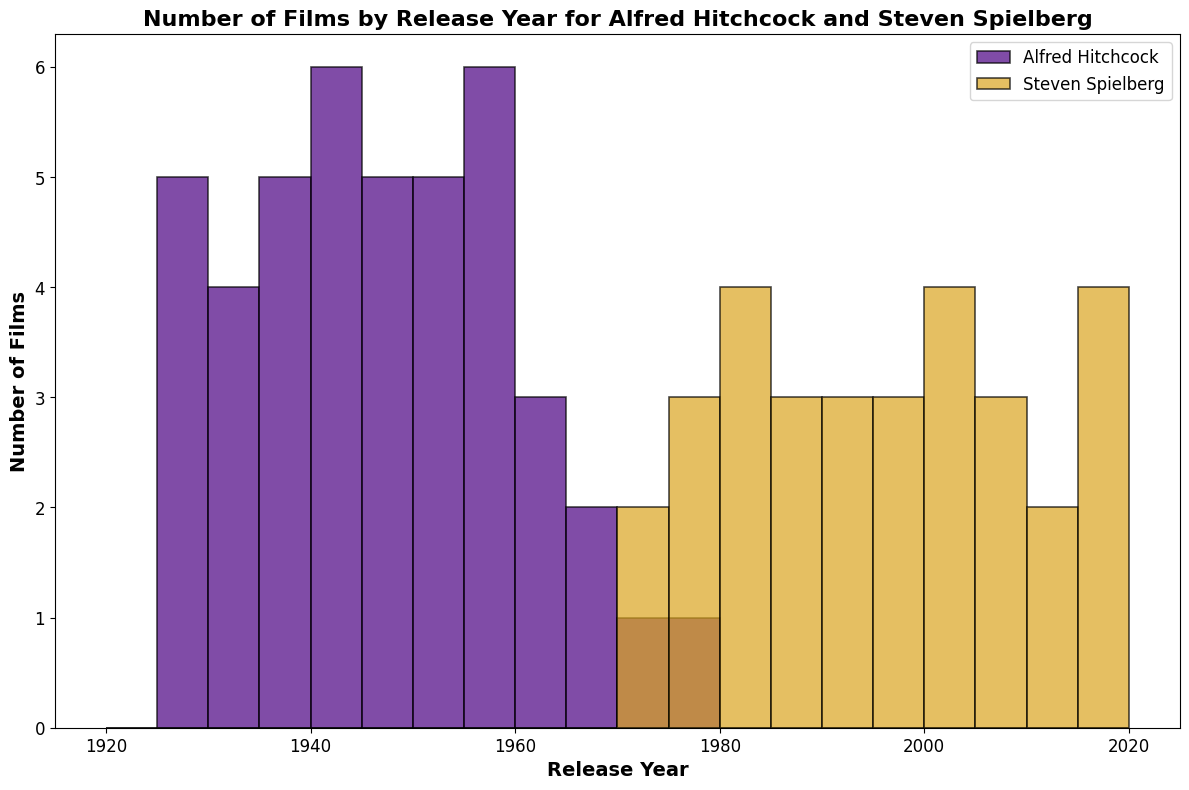Which director has more films released in the 1980s? To determine which director released more films in the 1980s, check the height of the bars corresponding to the years 1980-1989 for both directors. Spielberg has several films in this period, while Hitchcock has none. Therefore, Spielberg has more films in the 1980s.
Answer: Spielberg How many films did Alfred Hitchcock release between 1925 and 1940? Check the bars corresponding to Hitchcock's films for the years 1925 to 1940 and count the total number of films released. Adding up the values, the counts are 1 (1925), 2 (1927), 1 (1928), 1 (1929), 1 (1930), 1 (1931), 1 (1932), 1 (1934), 1 (1935), 2 (1936), 1 (1938), 1 (1939), 2 (1940). Thus, the total is 16.
Answer: 16 Which director released films over a longer time span? Compare the earliest and latest release years for each director. Hitchcock's earliest release is 1925 and latest is 1976, spanning 51 years. Spielberg's earliest release is 1971 and latest is 2022, spanning 51 years. Both directors have releases spanning 51 years.
Answer: Both In which 5-year bin did Steven Spielberg release the most films? Look at the height of the bars for Spielberg's films across all 5-year bins and identify the highest one. The tallest bar for Spielberg is in the 1995-1999 bin.
Answer: 1995-1999 How many films did Steven Spielberg release in the 2000s? Check the bars corresponding to Spielberg's films for the years 2000-2009 and sum the total number of films released. Adding up the values, the counts are 1 (2001), 2 (2002), 1 (2004), 2 (2005), 1 (2008). Thus, the total is 7.
Answer: 7 Who had more busy periods, Alfred Hitchcock or Steven Spielberg? Consider the number of 5-year bins where each director has a significant number of films. Hitchcock has multiple significant peaks (1925-1935, 1940-1960). Spielberg has several significant peaks in (1980-2000s). Although both directors have many busy periods, Spielberg's are more consistently high across bins.
Answer: Spielberg During which decade did Alfred Hitchcock release the most films? Check the height of the bars for Hitchcock's films across each decade. The tallest bars for Hitchcock are in the 1950s.
Answer: 1950s 